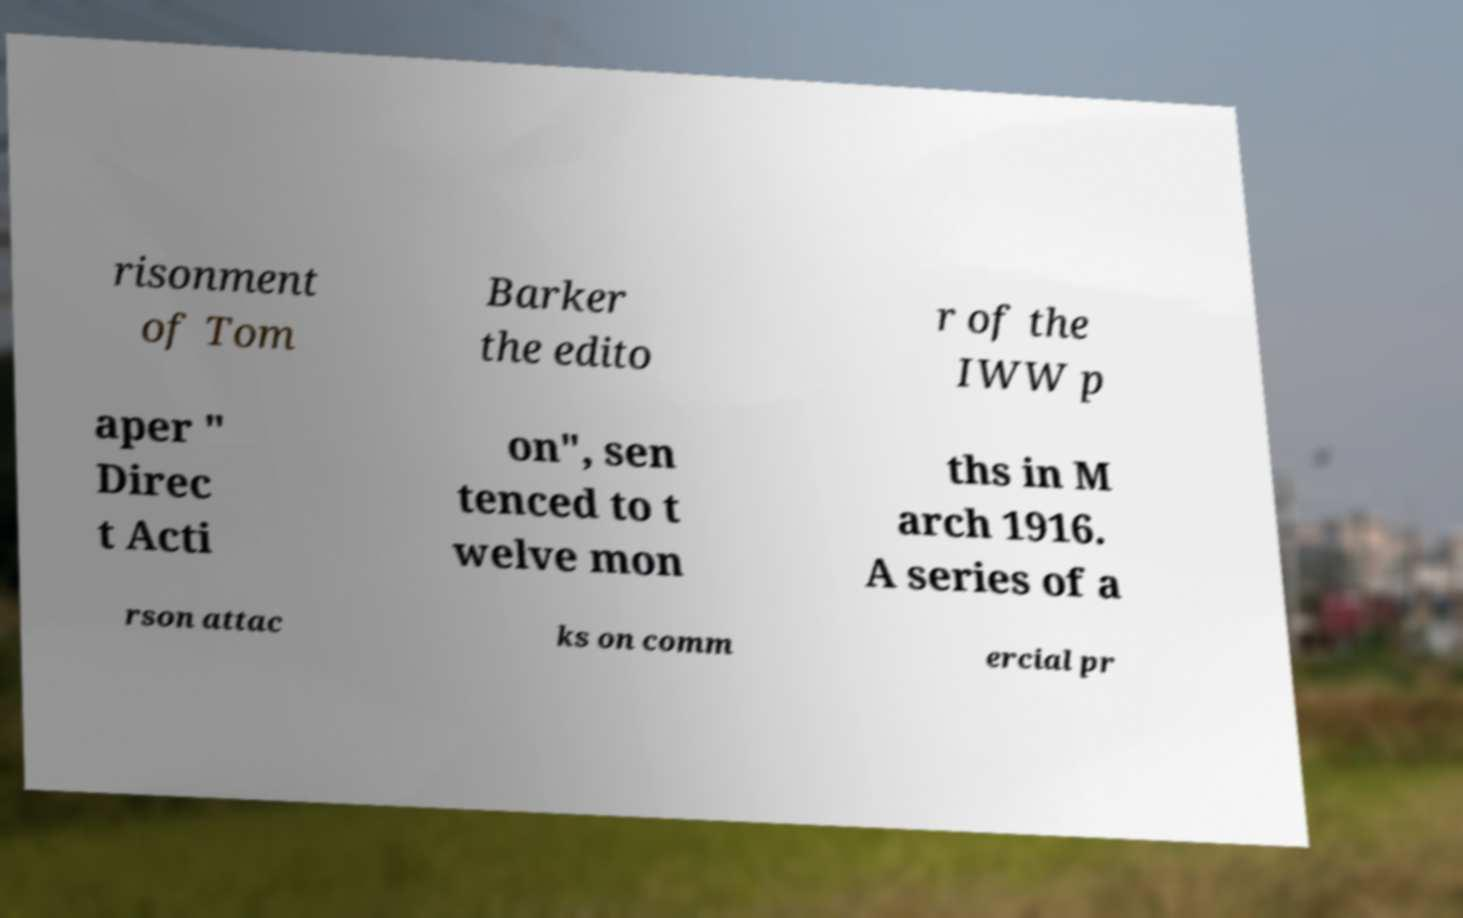Please read and relay the text visible in this image. What does it say? risonment of Tom Barker the edito r of the IWW p aper " Direc t Acti on", sen tenced to t welve mon ths in M arch 1916. A series of a rson attac ks on comm ercial pr 